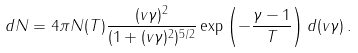Convert formula to latex. <formula><loc_0><loc_0><loc_500><loc_500>d N = 4 \pi N ( T ) \frac { ( v \gamma ) ^ { 2 } } { ( 1 + ( v \gamma ) ^ { 2 } ) ^ { 5 / 2 } } \exp \left ( - \frac { \gamma - 1 } { T } \right ) d ( v \gamma ) \, .</formula> 